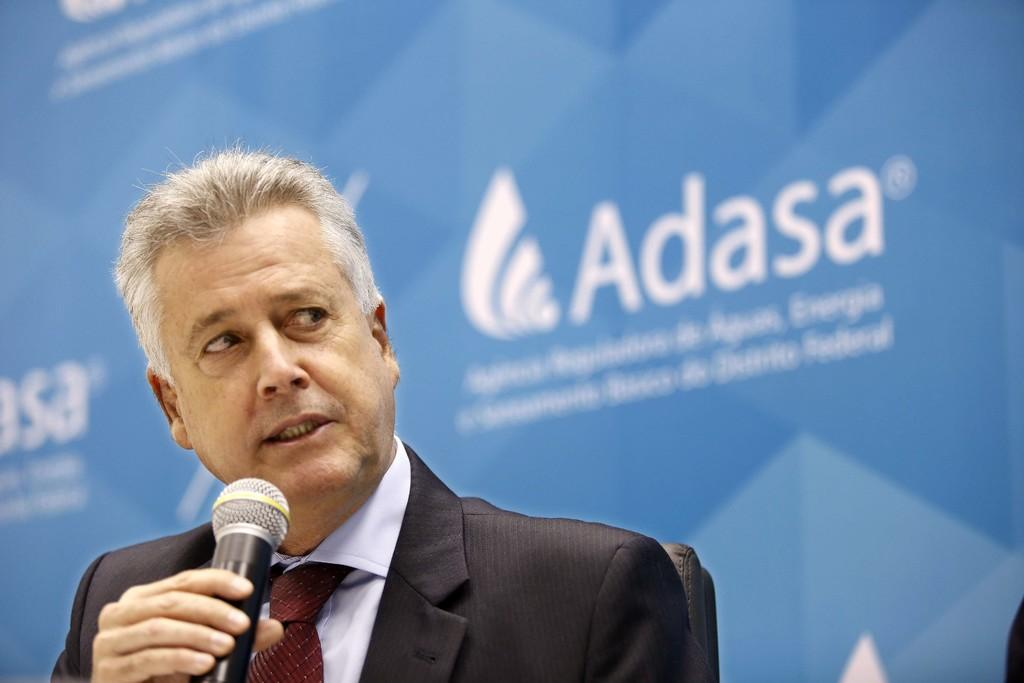What is the man in the image doing? The man is talking into a microphone. What type of clothing is the man wearing? The man is wearing a blazer, a tie, and a shirt. What can be seen in the background of the image? There are hoardings and advertisements in the background of the image. What type of game is the man playing in the image? There is no game being played in the image; the man is talking into a microphone. What type of treatment is the man receiving for his scarf in the image? There is no scarf or treatment mentioned in the image; the man is wearing a blazer, tie, and shirt. 